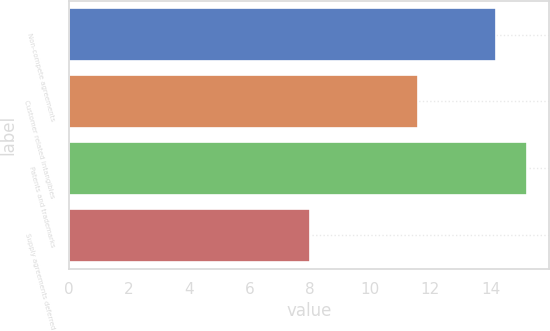Convert chart. <chart><loc_0><loc_0><loc_500><loc_500><bar_chart><fcel>Non-compete agreements<fcel>Customer related intangibles<fcel>Patents and trademarks<fcel>Supply agreements deferred<nl><fcel>14.2<fcel>11.6<fcel>15.2<fcel>8<nl></chart> 